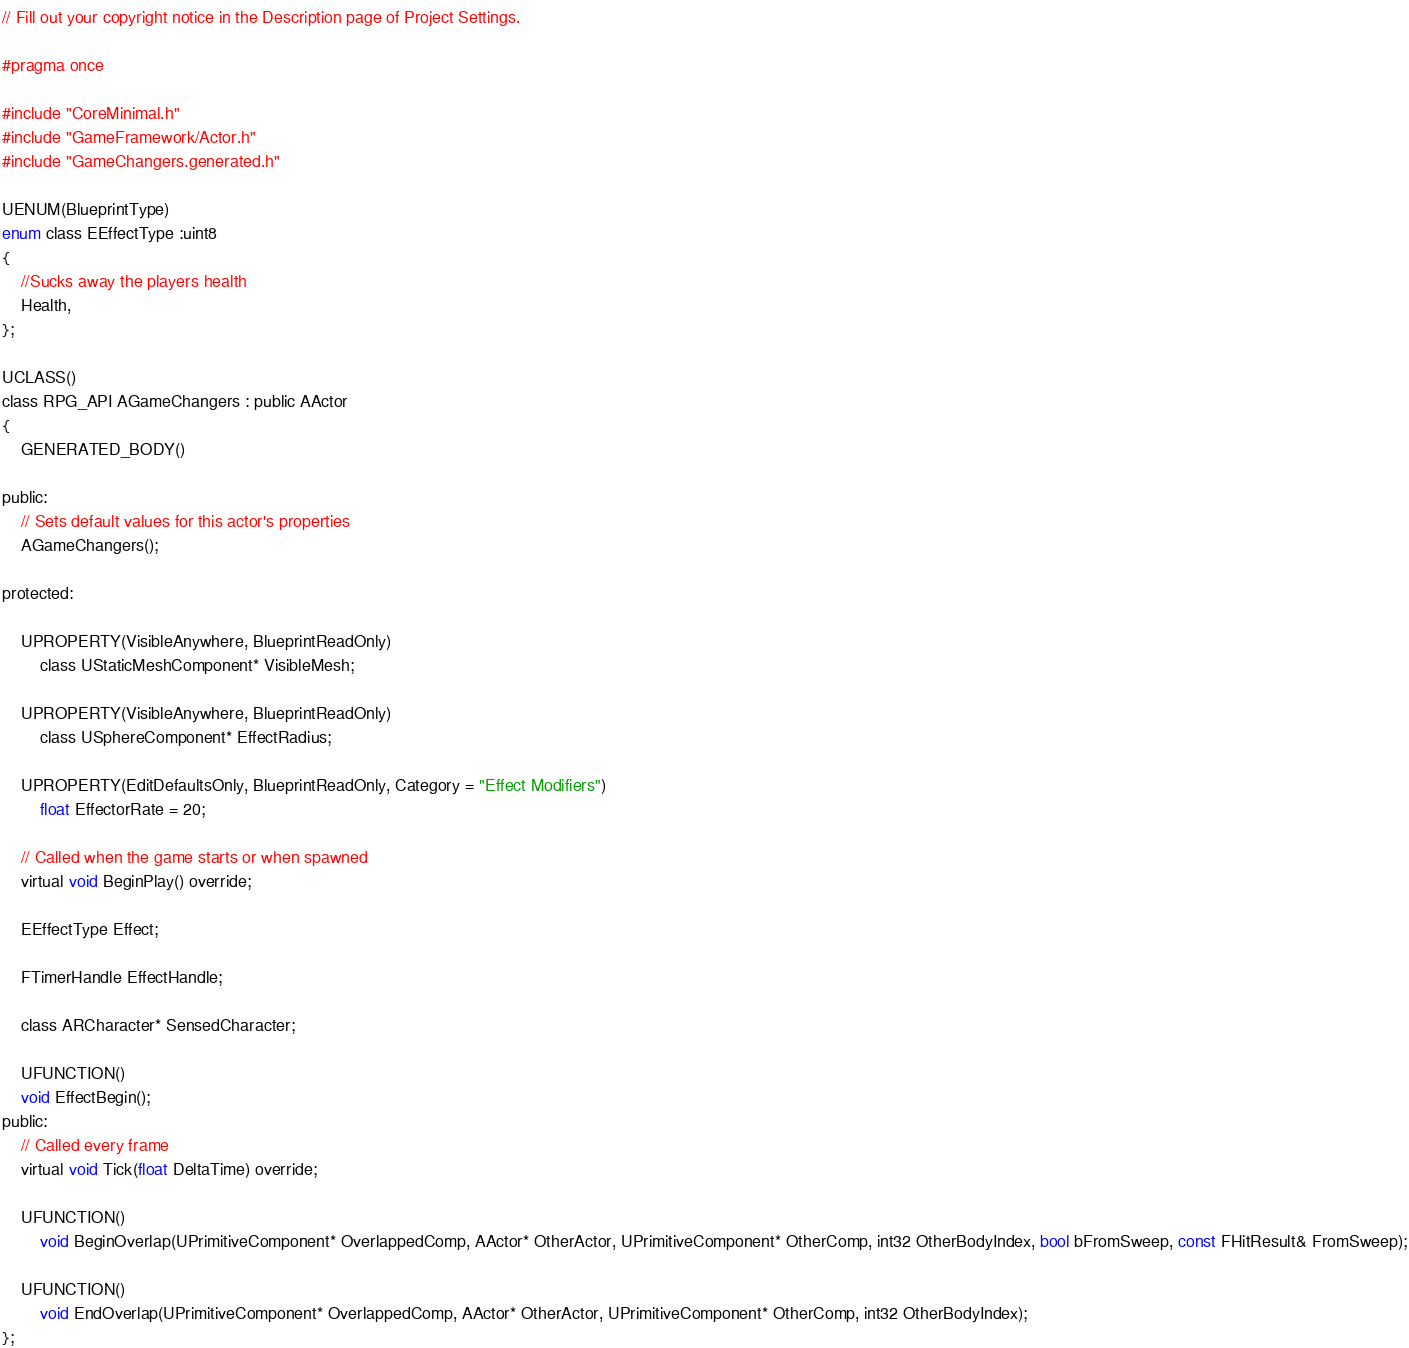<code> <loc_0><loc_0><loc_500><loc_500><_C_>// Fill out your copyright notice in the Description page of Project Settings.

#pragma once

#include "CoreMinimal.h"
#include "GameFramework/Actor.h"
#include "GameChangers.generated.h"

UENUM(BlueprintType)
enum class EEffectType :uint8
{
	//Sucks away the players health
	Health,
};

UCLASS()
class RPG_API AGameChangers : public AActor
{
	GENERATED_BODY()
	
public:	
	// Sets default values for this actor's properties
	AGameChangers();

protected:

	UPROPERTY(VisibleAnywhere, BlueprintReadOnly)
		class UStaticMeshComponent* VisibleMesh;

	UPROPERTY(VisibleAnywhere, BlueprintReadOnly)
		class USphereComponent* EffectRadius;

	UPROPERTY(EditDefaultsOnly, BlueprintReadOnly, Category = "Effect Modifiers")
		float EffectorRate = 20;

	// Called when the game starts or when spawned
	virtual void BeginPlay() override;

	EEffectType Effect;

	FTimerHandle EffectHandle;
	
	class ARCharacter* SensedCharacter;

	UFUNCTION()
	void EffectBegin();
public:	
	// Called every frame
	virtual void Tick(float DeltaTime) override;

	UFUNCTION()
		void BeginOverlap(UPrimitiveComponent* OverlappedComp, AActor* OtherActor, UPrimitiveComponent* OtherComp, int32 OtherBodyIndex, bool bFromSweep, const FHitResult& FromSweep);

	UFUNCTION()
		void EndOverlap(UPrimitiveComponent* OverlappedComp, AActor* OtherActor, UPrimitiveComponent* OtherComp, int32 OtherBodyIndex);
};
</code> 